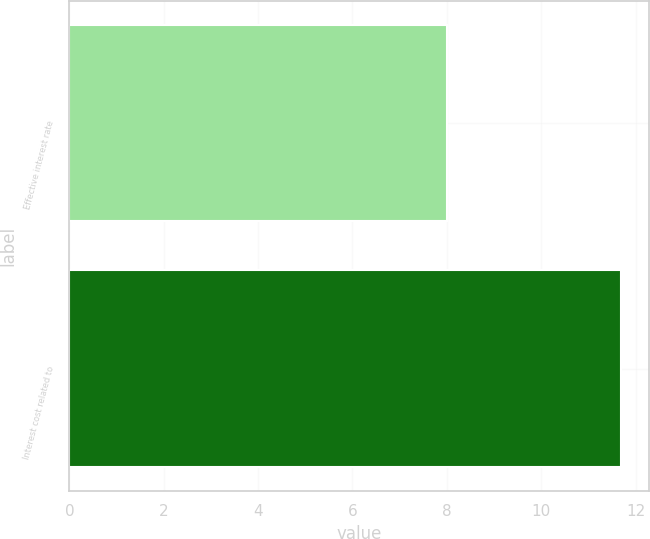Convert chart. <chart><loc_0><loc_0><loc_500><loc_500><bar_chart><fcel>Effective interest rate<fcel>Interest cost related to<nl><fcel>8<fcel>11.7<nl></chart> 